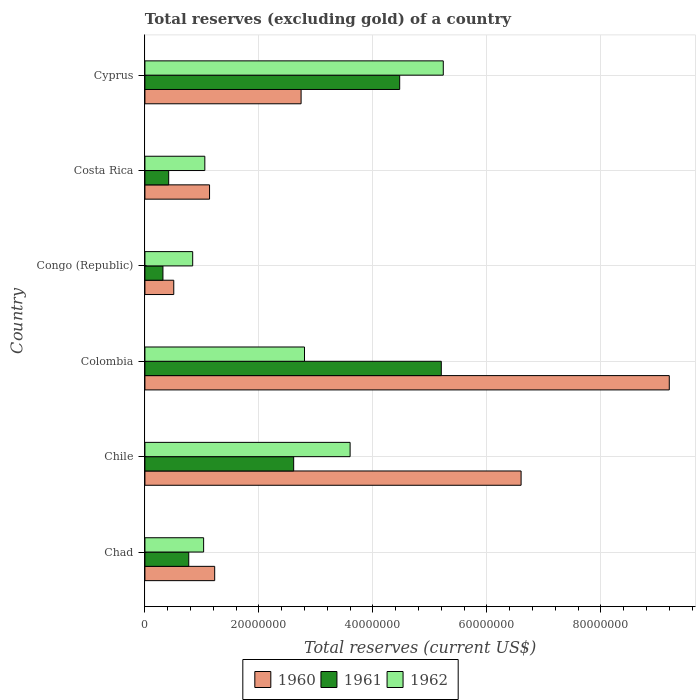How many different coloured bars are there?
Offer a very short reply. 3. How many groups of bars are there?
Give a very brief answer. 6. Are the number of bars per tick equal to the number of legend labels?
Keep it short and to the point. Yes. Are the number of bars on each tick of the Y-axis equal?
Your answer should be compact. Yes. How many bars are there on the 5th tick from the top?
Your answer should be very brief. 3. In how many cases, is the number of bars for a given country not equal to the number of legend labels?
Ensure brevity in your answer.  0. What is the total reserves (excluding gold) in 1961 in Colombia?
Give a very brief answer. 5.20e+07. Across all countries, what is the maximum total reserves (excluding gold) in 1960?
Your response must be concise. 9.20e+07. Across all countries, what is the minimum total reserves (excluding gold) in 1962?
Ensure brevity in your answer.  8.38e+06. In which country was the total reserves (excluding gold) in 1961 maximum?
Your response must be concise. Colombia. In which country was the total reserves (excluding gold) in 1962 minimum?
Your answer should be compact. Congo (Republic). What is the total total reserves (excluding gold) in 1960 in the graph?
Provide a short and direct response. 2.14e+08. What is the difference between the total reserves (excluding gold) in 1960 in Chad and that in Colombia?
Offer a terse response. -7.98e+07. What is the difference between the total reserves (excluding gold) in 1960 in Chile and the total reserves (excluding gold) in 1961 in Chad?
Provide a short and direct response. 5.83e+07. What is the average total reserves (excluding gold) in 1962 per country?
Provide a succinct answer. 2.43e+07. What is the difference between the total reserves (excluding gold) in 1960 and total reserves (excluding gold) in 1961 in Cyprus?
Give a very brief answer. -1.73e+07. What is the ratio of the total reserves (excluding gold) in 1960 in Chad to that in Cyprus?
Make the answer very short. 0.45. Is the difference between the total reserves (excluding gold) in 1960 in Congo (Republic) and Costa Rica greater than the difference between the total reserves (excluding gold) in 1961 in Congo (Republic) and Costa Rica?
Your answer should be compact. No. What is the difference between the highest and the second highest total reserves (excluding gold) in 1960?
Offer a very short reply. 2.60e+07. What is the difference between the highest and the lowest total reserves (excluding gold) in 1961?
Your response must be concise. 4.88e+07. In how many countries, is the total reserves (excluding gold) in 1962 greater than the average total reserves (excluding gold) in 1962 taken over all countries?
Offer a terse response. 3. How many bars are there?
Provide a succinct answer. 18. Are all the bars in the graph horizontal?
Offer a very short reply. Yes. Are the values on the major ticks of X-axis written in scientific E-notation?
Provide a succinct answer. No. Where does the legend appear in the graph?
Offer a very short reply. Bottom center. What is the title of the graph?
Your answer should be very brief. Total reserves (excluding gold) of a country. What is the label or title of the X-axis?
Keep it short and to the point. Total reserves (current US$). What is the label or title of the Y-axis?
Keep it short and to the point. Country. What is the Total reserves (current US$) in 1960 in Chad?
Provide a succinct answer. 1.22e+07. What is the Total reserves (current US$) of 1961 in Chad?
Your answer should be very brief. 7.69e+06. What is the Total reserves (current US$) in 1962 in Chad?
Ensure brevity in your answer.  1.03e+07. What is the Total reserves (current US$) in 1960 in Chile?
Give a very brief answer. 6.60e+07. What is the Total reserves (current US$) of 1961 in Chile?
Offer a terse response. 2.61e+07. What is the Total reserves (current US$) of 1962 in Chile?
Your answer should be compact. 3.60e+07. What is the Total reserves (current US$) in 1960 in Colombia?
Make the answer very short. 9.20e+07. What is the Total reserves (current US$) of 1961 in Colombia?
Make the answer very short. 5.20e+07. What is the Total reserves (current US$) of 1962 in Colombia?
Your answer should be compact. 2.80e+07. What is the Total reserves (current US$) in 1960 in Congo (Republic)?
Your answer should be very brief. 5.06e+06. What is the Total reserves (current US$) in 1961 in Congo (Republic)?
Offer a very short reply. 3.16e+06. What is the Total reserves (current US$) of 1962 in Congo (Republic)?
Keep it short and to the point. 8.38e+06. What is the Total reserves (current US$) of 1960 in Costa Rica?
Ensure brevity in your answer.  1.13e+07. What is the Total reserves (current US$) in 1961 in Costa Rica?
Your answer should be very brief. 4.17e+06. What is the Total reserves (current US$) of 1962 in Costa Rica?
Your answer should be compact. 1.05e+07. What is the Total reserves (current US$) of 1960 in Cyprus?
Provide a short and direct response. 2.74e+07. What is the Total reserves (current US$) in 1961 in Cyprus?
Provide a succinct answer. 4.47e+07. What is the Total reserves (current US$) in 1962 in Cyprus?
Your response must be concise. 5.23e+07. Across all countries, what is the maximum Total reserves (current US$) in 1960?
Make the answer very short. 9.20e+07. Across all countries, what is the maximum Total reserves (current US$) in 1961?
Your response must be concise. 5.20e+07. Across all countries, what is the maximum Total reserves (current US$) in 1962?
Keep it short and to the point. 5.23e+07. Across all countries, what is the minimum Total reserves (current US$) of 1960?
Keep it short and to the point. 5.06e+06. Across all countries, what is the minimum Total reserves (current US$) of 1961?
Ensure brevity in your answer.  3.16e+06. Across all countries, what is the minimum Total reserves (current US$) of 1962?
Offer a terse response. 8.38e+06. What is the total Total reserves (current US$) in 1960 in the graph?
Offer a very short reply. 2.14e+08. What is the total Total reserves (current US$) of 1961 in the graph?
Your answer should be compact. 1.38e+08. What is the total Total reserves (current US$) of 1962 in the graph?
Offer a very short reply. 1.46e+08. What is the difference between the Total reserves (current US$) in 1960 in Chad and that in Chile?
Provide a succinct answer. -5.38e+07. What is the difference between the Total reserves (current US$) in 1961 in Chad and that in Chile?
Your response must be concise. -1.84e+07. What is the difference between the Total reserves (current US$) of 1962 in Chad and that in Chile?
Keep it short and to the point. -2.57e+07. What is the difference between the Total reserves (current US$) of 1960 in Chad and that in Colombia?
Your answer should be very brief. -7.98e+07. What is the difference between the Total reserves (current US$) in 1961 in Chad and that in Colombia?
Provide a short and direct response. -4.43e+07. What is the difference between the Total reserves (current US$) in 1962 in Chad and that in Colombia?
Give a very brief answer. -1.77e+07. What is the difference between the Total reserves (current US$) of 1960 in Chad and that in Congo (Republic)?
Provide a succinct answer. 7.18e+06. What is the difference between the Total reserves (current US$) of 1961 in Chad and that in Congo (Republic)?
Give a very brief answer. 4.53e+06. What is the difference between the Total reserves (current US$) in 1962 in Chad and that in Congo (Republic)?
Your answer should be very brief. 1.92e+06. What is the difference between the Total reserves (current US$) of 1960 in Chad and that in Costa Rica?
Your answer should be compact. 9.00e+05. What is the difference between the Total reserves (current US$) of 1961 in Chad and that in Costa Rica?
Provide a succinct answer. 3.52e+06. What is the difference between the Total reserves (current US$) in 1962 in Chad and that in Costa Rica?
Your answer should be compact. -2.10e+05. What is the difference between the Total reserves (current US$) in 1960 in Chad and that in Cyprus?
Keep it short and to the point. -1.52e+07. What is the difference between the Total reserves (current US$) in 1961 in Chad and that in Cyprus?
Provide a short and direct response. -3.70e+07. What is the difference between the Total reserves (current US$) in 1962 in Chad and that in Cyprus?
Provide a succinct answer. -4.20e+07. What is the difference between the Total reserves (current US$) in 1960 in Chile and that in Colombia?
Your response must be concise. -2.60e+07. What is the difference between the Total reserves (current US$) of 1961 in Chile and that in Colombia?
Your response must be concise. -2.59e+07. What is the difference between the Total reserves (current US$) of 1960 in Chile and that in Congo (Republic)?
Keep it short and to the point. 6.09e+07. What is the difference between the Total reserves (current US$) of 1961 in Chile and that in Congo (Republic)?
Offer a terse response. 2.29e+07. What is the difference between the Total reserves (current US$) in 1962 in Chile and that in Congo (Republic)?
Keep it short and to the point. 2.76e+07. What is the difference between the Total reserves (current US$) of 1960 in Chile and that in Costa Rica?
Provide a succinct answer. 5.47e+07. What is the difference between the Total reserves (current US$) in 1961 in Chile and that in Costa Rica?
Ensure brevity in your answer.  2.19e+07. What is the difference between the Total reserves (current US$) in 1962 in Chile and that in Costa Rica?
Your answer should be compact. 2.55e+07. What is the difference between the Total reserves (current US$) in 1960 in Chile and that in Cyprus?
Offer a terse response. 3.86e+07. What is the difference between the Total reserves (current US$) in 1961 in Chile and that in Cyprus?
Offer a very short reply. -1.86e+07. What is the difference between the Total reserves (current US$) of 1962 in Chile and that in Cyprus?
Give a very brief answer. -1.63e+07. What is the difference between the Total reserves (current US$) in 1960 in Colombia and that in Congo (Republic)?
Provide a short and direct response. 8.69e+07. What is the difference between the Total reserves (current US$) of 1961 in Colombia and that in Congo (Republic)?
Your answer should be compact. 4.88e+07. What is the difference between the Total reserves (current US$) in 1962 in Colombia and that in Congo (Republic)?
Offer a very short reply. 1.96e+07. What is the difference between the Total reserves (current US$) of 1960 in Colombia and that in Costa Rica?
Ensure brevity in your answer.  8.07e+07. What is the difference between the Total reserves (current US$) of 1961 in Colombia and that in Costa Rica?
Give a very brief answer. 4.78e+07. What is the difference between the Total reserves (current US$) in 1962 in Colombia and that in Costa Rica?
Your answer should be very brief. 1.75e+07. What is the difference between the Total reserves (current US$) of 1960 in Colombia and that in Cyprus?
Give a very brief answer. 6.46e+07. What is the difference between the Total reserves (current US$) of 1961 in Colombia and that in Cyprus?
Give a very brief answer. 7.30e+06. What is the difference between the Total reserves (current US$) of 1962 in Colombia and that in Cyprus?
Provide a short and direct response. -2.43e+07. What is the difference between the Total reserves (current US$) of 1960 in Congo (Republic) and that in Costa Rica?
Offer a terse response. -6.28e+06. What is the difference between the Total reserves (current US$) in 1961 in Congo (Republic) and that in Costa Rica?
Ensure brevity in your answer.  -1.01e+06. What is the difference between the Total reserves (current US$) in 1962 in Congo (Republic) and that in Costa Rica?
Ensure brevity in your answer.  -2.13e+06. What is the difference between the Total reserves (current US$) of 1960 in Congo (Republic) and that in Cyprus?
Give a very brief answer. -2.23e+07. What is the difference between the Total reserves (current US$) in 1961 in Congo (Republic) and that in Cyprus?
Provide a succinct answer. -4.15e+07. What is the difference between the Total reserves (current US$) in 1962 in Congo (Republic) and that in Cyprus?
Make the answer very short. -4.40e+07. What is the difference between the Total reserves (current US$) in 1960 in Costa Rica and that in Cyprus?
Offer a very short reply. -1.61e+07. What is the difference between the Total reserves (current US$) of 1961 in Costa Rica and that in Cyprus?
Your answer should be very brief. -4.05e+07. What is the difference between the Total reserves (current US$) of 1962 in Costa Rica and that in Cyprus?
Offer a very short reply. -4.18e+07. What is the difference between the Total reserves (current US$) in 1960 in Chad and the Total reserves (current US$) in 1961 in Chile?
Keep it short and to the point. -1.39e+07. What is the difference between the Total reserves (current US$) of 1960 in Chad and the Total reserves (current US$) of 1962 in Chile?
Your response must be concise. -2.38e+07. What is the difference between the Total reserves (current US$) of 1961 in Chad and the Total reserves (current US$) of 1962 in Chile?
Make the answer very short. -2.83e+07. What is the difference between the Total reserves (current US$) in 1960 in Chad and the Total reserves (current US$) in 1961 in Colombia?
Ensure brevity in your answer.  -3.98e+07. What is the difference between the Total reserves (current US$) in 1960 in Chad and the Total reserves (current US$) in 1962 in Colombia?
Your response must be concise. -1.58e+07. What is the difference between the Total reserves (current US$) of 1961 in Chad and the Total reserves (current US$) of 1962 in Colombia?
Offer a very short reply. -2.03e+07. What is the difference between the Total reserves (current US$) in 1960 in Chad and the Total reserves (current US$) in 1961 in Congo (Republic)?
Your answer should be very brief. 9.08e+06. What is the difference between the Total reserves (current US$) of 1960 in Chad and the Total reserves (current US$) of 1962 in Congo (Republic)?
Ensure brevity in your answer.  3.86e+06. What is the difference between the Total reserves (current US$) of 1961 in Chad and the Total reserves (current US$) of 1962 in Congo (Republic)?
Offer a very short reply. -6.90e+05. What is the difference between the Total reserves (current US$) in 1960 in Chad and the Total reserves (current US$) in 1961 in Costa Rica?
Provide a short and direct response. 8.07e+06. What is the difference between the Total reserves (current US$) in 1960 in Chad and the Total reserves (current US$) in 1962 in Costa Rica?
Provide a succinct answer. 1.73e+06. What is the difference between the Total reserves (current US$) in 1961 in Chad and the Total reserves (current US$) in 1962 in Costa Rica?
Give a very brief answer. -2.82e+06. What is the difference between the Total reserves (current US$) in 1960 in Chad and the Total reserves (current US$) in 1961 in Cyprus?
Make the answer very short. -3.25e+07. What is the difference between the Total reserves (current US$) in 1960 in Chad and the Total reserves (current US$) in 1962 in Cyprus?
Your response must be concise. -4.01e+07. What is the difference between the Total reserves (current US$) in 1961 in Chad and the Total reserves (current US$) in 1962 in Cyprus?
Provide a succinct answer. -4.47e+07. What is the difference between the Total reserves (current US$) of 1960 in Chile and the Total reserves (current US$) of 1961 in Colombia?
Ensure brevity in your answer.  1.40e+07. What is the difference between the Total reserves (current US$) in 1960 in Chile and the Total reserves (current US$) in 1962 in Colombia?
Your answer should be very brief. 3.80e+07. What is the difference between the Total reserves (current US$) of 1961 in Chile and the Total reserves (current US$) of 1962 in Colombia?
Ensure brevity in your answer.  -1.90e+06. What is the difference between the Total reserves (current US$) of 1960 in Chile and the Total reserves (current US$) of 1961 in Congo (Republic)?
Give a very brief answer. 6.28e+07. What is the difference between the Total reserves (current US$) in 1960 in Chile and the Total reserves (current US$) in 1962 in Congo (Republic)?
Keep it short and to the point. 5.76e+07. What is the difference between the Total reserves (current US$) of 1961 in Chile and the Total reserves (current US$) of 1962 in Congo (Republic)?
Your answer should be very brief. 1.77e+07. What is the difference between the Total reserves (current US$) of 1960 in Chile and the Total reserves (current US$) of 1961 in Costa Rica?
Ensure brevity in your answer.  6.18e+07. What is the difference between the Total reserves (current US$) of 1960 in Chile and the Total reserves (current US$) of 1962 in Costa Rica?
Your response must be concise. 5.55e+07. What is the difference between the Total reserves (current US$) in 1961 in Chile and the Total reserves (current US$) in 1962 in Costa Rica?
Your answer should be compact. 1.56e+07. What is the difference between the Total reserves (current US$) of 1960 in Chile and the Total reserves (current US$) of 1961 in Cyprus?
Offer a terse response. 2.13e+07. What is the difference between the Total reserves (current US$) in 1960 in Chile and the Total reserves (current US$) in 1962 in Cyprus?
Your answer should be very brief. 1.37e+07. What is the difference between the Total reserves (current US$) in 1961 in Chile and the Total reserves (current US$) in 1962 in Cyprus?
Provide a succinct answer. -2.62e+07. What is the difference between the Total reserves (current US$) in 1960 in Colombia and the Total reserves (current US$) in 1961 in Congo (Republic)?
Give a very brief answer. 8.88e+07. What is the difference between the Total reserves (current US$) in 1960 in Colombia and the Total reserves (current US$) in 1962 in Congo (Republic)?
Provide a succinct answer. 8.36e+07. What is the difference between the Total reserves (current US$) in 1961 in Colombia and the Total reserves (current US$) in 1962 in Congo (Republic)?
Make the answer very short. 4.36e+07. What is the difference between the Total reserves (current US$) of 1960 in Colombia and the Total reserves (current US$) of 1961 in Costa Rica?
Provide a short and direct response. 8.78e+07. What is the difference between the Total reserves (current US$) in 1960 in Colombia and the Total reserves (current US$) in 1962 in Costa Rica?
Provide a succinct answer. 8.15e+07. What is the difference between the Total reserves (current US$) of 1961 in Colombia and the Total reserves (current US$) of 1962 in Costa Rica?
Keep it short and to the point. 4.15e+07. What is the difference between the Total reserves (current US$) in 1960 in Colombia and the Total reserves (current US$) in 1961 in Cyprus?
Provide a succinct answer. 4.73e+07. What is the difference between the Total reserves (current US$) in 1960 in Colombia and the Total reserves (current US$) in 1962 in Cyprus?
Offer a very short reply. 3.96e+07. What is the difference between the Total reserves (current US$) in 1961 in Colombia and the Total reserves (current US$) in 1962 in Cyprus?
Keep it short and to the point. -3.50e+05. What is the difference between the Total reserves (current US$) in 1960 in Congo (Republic) and the Total reserves (current US$) in 1961 in Costa Rica?
Your answer should be compact. 8.90e+05. What is the difference between the Total reserves (current US$) in 1960 in Congo (Republic) and the Total reserves (current US$) in 1962 in Costa Rica?
Offer a terse response. -5.45e+06. What is the difference between the Total reserves (current US$) in 1961 in Congo (Republic) and the Total reserves (current US$) in 1962 in Costa Rica?
Your answer should be compact. -7.35e+06. What is the difference between the Total reserves (current US$) of 1960 in Congo (Republic) and the Total reserves (current US$) of 1961 in Cyprus?
Make the answer very short. -3.96e+07. What is the difference between the Total reserves (current US$) of 1960 in Congo (Republic) and the Total reserves (current US$) of 1962 in Cyprus?
Provide a short and direct response. -4.73e+07. What is the difference between the Total reserves (current US$) in 1961 in Congo (Republic) and the Total reserves (current US$) in 1962 in Cyprus?
Make the answer very short. -4.92e+07. What is the difference between the Total reserves (current US$) in 1960 in Costa Rica and the Total reserves (current US$) in 1961 in Cyprus?
Offer a very short reply. -3.34e+07. What is the difference between the Total reserves (current US$) in 1960 in Costa Rica and the Total reserves (current US$) in 1962 in Cyprus?
Ensure brevity in your answer.  -4.10e+07. What is the difference between the Total reserves (current US$) in 1961 in Costa Rica and the Total reserves (current US$) in 1962 in Cyprus?
Keep it short and to the point. -4.82e+07. What is the average Total reserves (current US$) of 1960 per country?
Give a very brief answer. 3.57e+07. What is the average Total reserves (current US$) of 1961 per country?
Provide a short and direct response. 2.30e+07. What is the average Total reserves (current US$) in 1962 per country?
Give a very brief answer. 2.43e+07. What is the difference between the Total reserves (current US$) of 1960 and Total reserves (current US$) of 1961 in Chad?
Your answer should be very brief. 4.55e+06. What is the difference between the Total reserves (current US$) of 1960 and Total reserves (current US$) of 1962 in Chad?
Your response must be concise. 1.94e+06. What is the difference between the Total reserves (current US$) of 1961 and Total reserves (current US$) of 1962 in Chad?
Provide a succinct answer. -2.61e+06. What is the difference between the Total reserves (current US$) in 1960 and Total reserves (current US$) in 1961 in Chile?
Give a very brief answer. 3.99e+07. What is the difference between the Total reserves (current US$) in 1960 and Total reserves (current US$) in 1962 in Chile?
Provide a short and direct response. 3.00e+07. What is the difference between the Total reserves (current US$) in 1961 and Total reserves (current US$) in 1962 in Chile?
Ensure brevity in your answer.  -9.90e+06. What is the difference between the Total reserves (current US$) in 1960 and Total reserves (current US$) in 1961 in Colombia?
Give a very brief answer. 4.00e+07. What is the difference between the Total reserves (current US$) in 1960 and Total reserves (current US$) in 1962 in Colombia?
Provide a succinct answer. 6.40e+07. What is the difference between the Total reserves (current US$) in 1961 and Total reserves (current US$) in 1962 in Colombia?
Provide a short and direct response. 2.40e+07. What is the difference between the Total reserves (current US$) in 1960 and Total reserves (current US$) in 1961 in Congo (Republic)?
Your response must be concise. 1.90e+06. What is the difference between the Total reserves (current US$) in 1960 and Total reserves (current US$) in 1962 in Congo (Republic)?
Provide a succinct answer. -3.32e+06. What is the difference between the Total reserves (current US$) of 1961 and Total reserves (current US$) of 1962 in Congo (Republic)?
Your answer should be very brief. -5.22e+06. What is the difference between the Total reserves (current US$) in 1960 and Total reserves (current US$) in 1961 in Costa Rica?
Your response must be concise. 7.17e+06. What is the difference between the Total reserves (current US$) of 1960 and Total reserves (current US$) of 1962 in Costa Rica?
Provide a short and direct response. 8.30e+05. What is the difference between the Total reserves (current US$) in 1961 and Total reserves (current US$) in 1962 in Costa Rica?
Ensure brevity in your answer.  -6.34e+06. What is the difference between the Total reserves (current US$) of 1960 and Total reserves (current US$) of 1961 in Cyprus?
Offer a very short reply. -1.73e+07. What is the difference between the Total reserves (current US$) in 1960 and Total reserves (current US$) in 1962 in Cyprus?
Provide a short and direct response. -2.49e+07. What is the difference between the Total reserves (current US$) in 1961 and Total reserves (current US$) in 1962 in Cyprus?
Give a very brief answer. -7.65e+06. What is the ratio of the Total reserves (current US$) in 1960 in Chad to that in Chile?
Offer a terse response. 0.19. What is the ratio of the Total reserves (current US$) of 1961 in Chad to that in Chile?
Your answer should be very brief. 0.29. What is the ratio of the Total reserves (current US$) in 1962 in Chad to that in Chile?
Your response must be concise. 0.29. What is the ratio of the Total reserves (current US$) of 1960 in Chad to that in Colombia?
Make the answer very short. 0.13. What is the ratio of the Total reserves (current US$) in 1961 in Chad to that in Colombia?
Provide a short and direct response. 0.15. What is the ratio of the Total reserves (current US$) of 1962 in Chad to that in Colombia?
Your response must be concise. 0.37. What is the ratio of the Total reserves (current US$) of 1960 in Chad to that in Congo (Republic)?
Make the answer very short. 2.42. What is the ratio of the Total reserves (current US$) in 1961 in Chad to that in Congo (Republic)?
Your answer should be very brief. 2.43. What is the ratio of the Total reserves (current US$) in 1962 in Chad to that in Congo (Republic)?
Your answer should be very brief. 1.23. What is the ratio of the Total reserves (current US$) in 1960 in Chad to that in Costa Rica?
Keep it short and to the point. 1.08. What is the ratio of the Total reserves (current US$) of 1961 in Chad to that in Costa Rica?
Your answer should be very brief. 1.84. What is the ratio of the Total reserves (current US$) of 1960 in Chad to that in Cyprus?
Your response must be concise. 0.45. What is the ratio of the Total reserves (current US$) in 1961 in Chad to that in Cyprus?
Your answer should be very brief. 0.17. What is the ratio of the Total reserves (current US$) in 1962 in Chad to that in Cyprus?
Offer a very short reply. 0.2. What is the ratio of the Total reserves (current US$) of 1960 in Chile to that in Colombia?
Your answer should be very brief. 0.72. What is the ratio of the Total reserves (current US$) in 1961 in Chile to that in Colombia?
Your response must be concise. 0.5. What is the ratio of the Total reserves (current US$) of 1960 in Chile to that in Congo (Republic)?
Provide a succinct answer. 13.04. What is the ratio of the Total reserves (current US$) in 1961 in Chile to that in Congo (Republic)?
Your answer should be very brief. 8.26. What is the ratio of the Total reserves (current US$) in 1962 in Chile to that in Congo (Republic)?
Offer a very short reply. 4.3. What is the ratio of the Total reserves (current US$) of 1960 in Chile to that in Costa Rica?
Your answer should be very brief. 5.82. What is the ratio of the Total reserves (current US$) of 1961 in Chile to that in Costa Rica?
Provide a short and direct response. 6.26. What is the ratio of the Total reserves (current US$) of 1962 in Chile to that in Costa Rica?
Give a very brief answer. 3.43. What is the ratio of the Total reserves (current US$) of 1960 in Chile to that in Cyprus?
Offer a terse response. 2.41. What is the ratio of the Total reserves (current US$) in 1961 in Chile to that in Cyprus?
Your answer should be very brief. 0.58. What is the ratio of the Total reserves (current US$) in 1962 in Chile to that in Cyprus?
Offer a very short reply. 0.69. What is the ratio of the Total reserves (current US$) in 1960 in Colombia to that in Congo (Republic)?
Provide a short and direct response. 18.18. What is the ratio of the Total reserves (current US$) of 1961 in Colombia to that in Congo (Republic)?
Offer a very short reply. 16.46. What is the ratio of the Total reserves (current US$) of 1962 in Colombia to that in Congo (Republic)?
Provide a succinct answer. 3.34. What is the ratio of the Total reserves (current US$) of 1960 in Colombia to that in Costa Rica?
Ensure brevity in your answer.  8.11. What is the ratio of the Total reserves (current US$) of 1961 in Colombia to that in Costa Rica?
Provide a succinct answer. 12.47. What is the ratio of the Total reserves (current US$) in 1962 in Colombia to that in Costa Rica?
Your answer should be very brief. 2.66. What is the ratio of the Total reserves (current US$) of 1960 in Colombia to that in Cyprus?
Your response must be concise. 3.36. What is the ratio of the Total reserves (current US$) of 1961 in Colombia to that in Cyprus?
Offer a very short reply. 1.16. What is the ratio of the Total reserves (current US$) of 1962 in Colombia to that in Cyprus?
Provide a short and direct response. 0.53. What is the ratio of the Total reserves (current US$) in 1960 in Congo (Republic) to that in Costa Rica?
Keep it short and to the point. 0.45. What is the ratio of the Total reserves (current US$) in 1961 in Congo (Republic) to that in Costa Rica?
Offer a very short reply. 0.76. What is the ratio of the Total reserves (current US$) of 1962 in Congo (Republic) to that in Costa Rica?
Your answer should be compact. 0.8. What is the ratio of the Total reserves (current US$) in 1960 in Congo (Republic) to that in Cyprus?
Offer a very short reply. 0.18. What is the ratio of the Total reserves (current US$) in 1961 in Congo (Republic) to that in Cyprus?
Provide a succinct answer. 0.07. What is the ratio of the Total reserves (current US$) of 1962 in Congo (Republic) to that in Cyprus?
Offer a very short reply. 0.16. What is the ratio of the Total reserves (current US$) in 1960 in Costa Rica to that in Cyprus?
Offer a very short reply. 0.41. What is the ratio of the Total reserves (current US$) of 1961 in Costa Rica to that in Cyprus?
Offer a very short reply. 0.09. What is the ratio of the Total reserves (current US$) in 1962 in Costa Rica to that in Cyprus?
Ensure brevity in your answer.  0.2. What is the difference between the highest and the second highest Total reserves (current US$) of 1960?
Your answer should be compact. 2.60e+07. What is the difference between the highest and the second highest Total reserves (current US$) in 1961?
Provide a short and direct response. 7.30e+06. What is the difference between the highest and the second highest Total reserves (current US$) of 1962?
Provide a succinct answer. 1.63e+07. What is the difference between the highest and the lowest Total reserves (current US$) of 1960?
Ensure brevity in your answer.  8.69e+07. What is the difference between the highest and the lowest Total reserves (current US$) in 1961?
Offer a very short reply. 4.88e+07. What is the difference between the highest and the lowest Total reserves (current US$) of 1962?
Provide a short and direct response. 4.40e+07. 